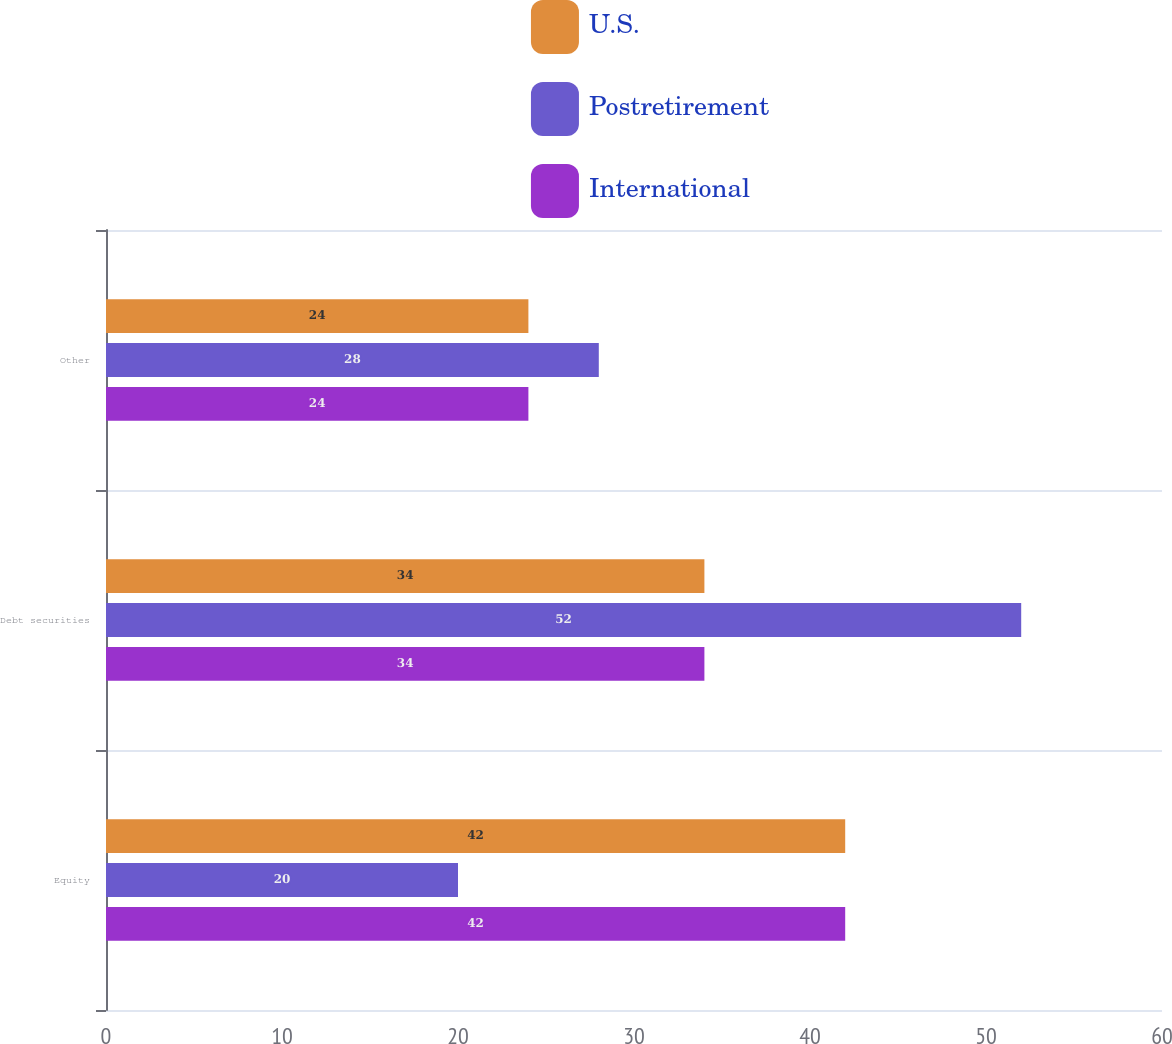<chart> <loc_0><loc_0><loc_500><loc_500><stacked_bar_chart><ecel><fcel>Equity<fcel>Debt securities<fcel>Other<nl><fcel>U.S.<fcel>42<fcel>34<fcel>24<nl><fcel>Postretirement<fcel>20<fcel>52<fcel>28<nl><fcel>International<fcel>42<fcel>34<fcel>24<nl></chart> 